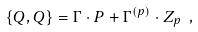<formula> <loc_0><loc_0><loc_500><loc_500>\{ Q , Q \} = \Gamma \cdot P + \Gamma ^ { ( p ) } \cdot Z _ { p } \ ,</formula> 